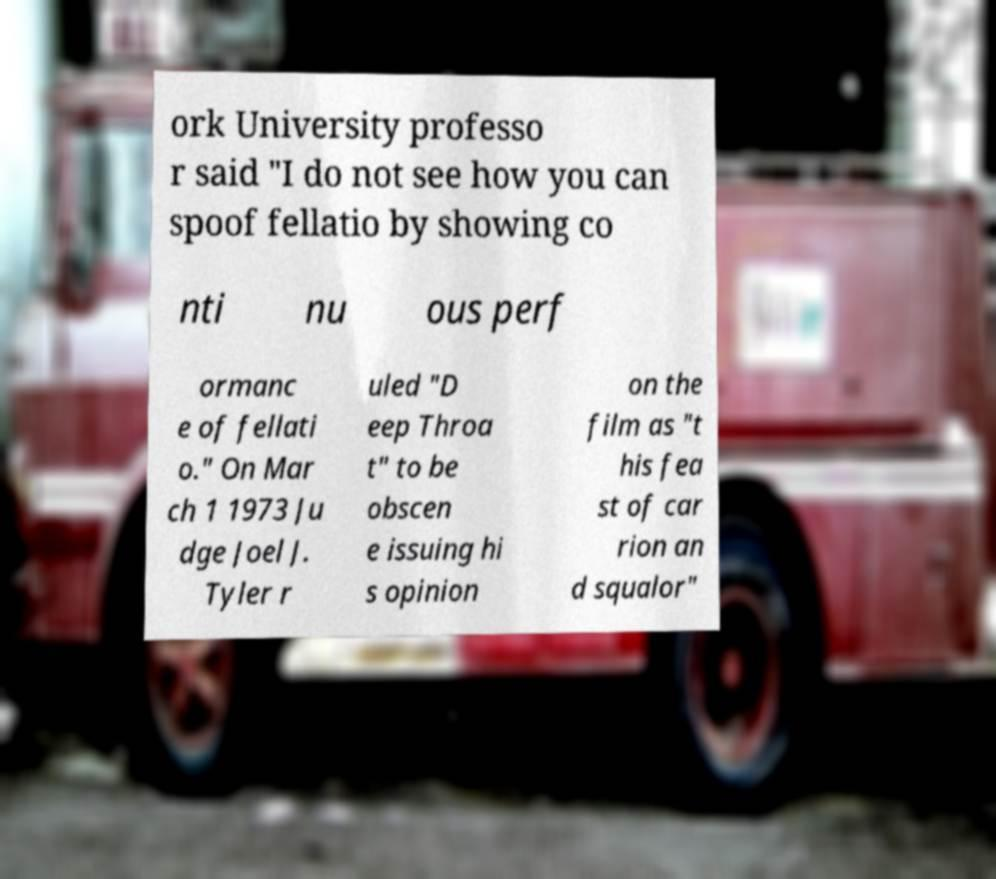Could you extract and type out the text from this image? ork University professo r said "I do not see how you can spoof fellatio by showing co nti nu ous perf ormanc e of fellati o." On Mar ch 1 1973 Ju dge Joel J. Tyler r uled "D eep Throa t" to be obscen e issuing hi s opinion on the film as "t his fea st of car rion an d squalor" 